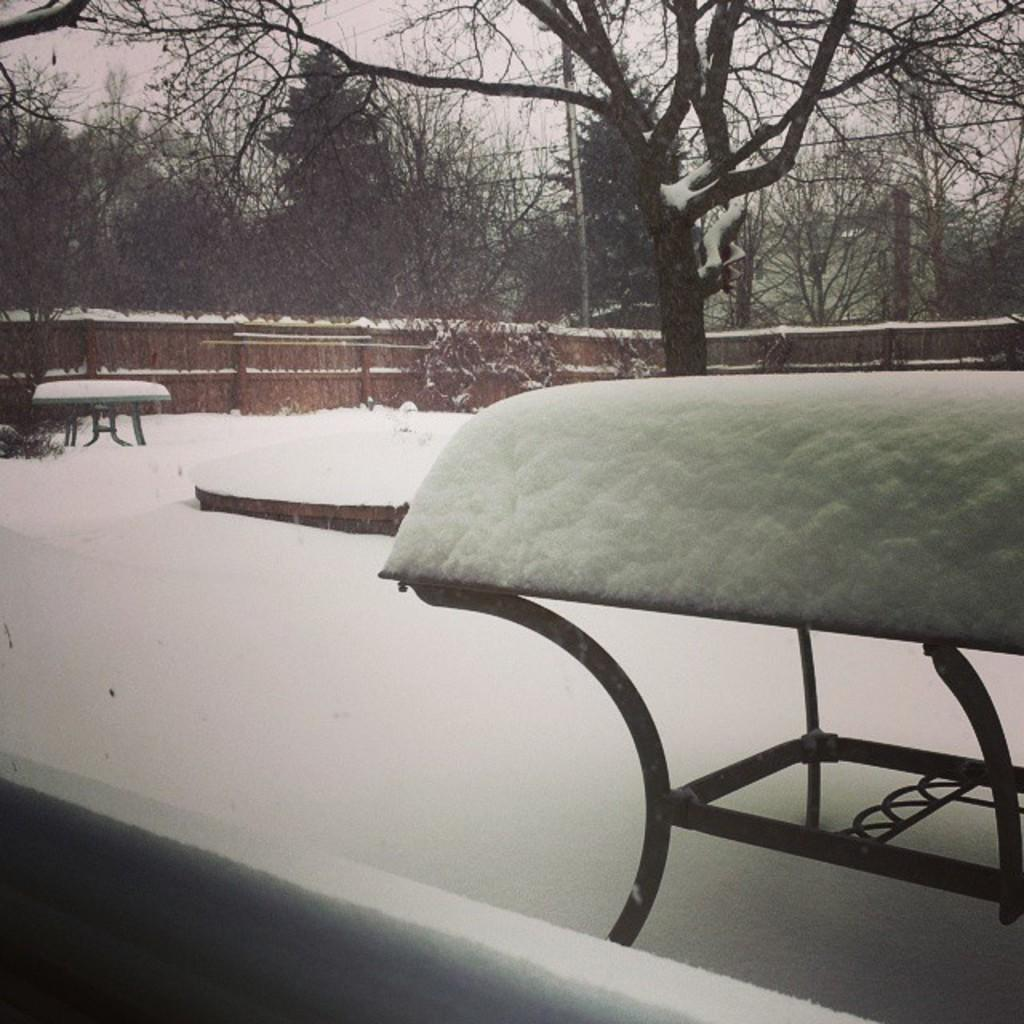What is the condition of the ground in the image? The ground is covered in snow. How many tables are on the ground in the image? There are two tables on the ground. What can be seen in the background of the image? There are trees, a wall, wires, and the sky visible in the background. Can you see a clam hanging from the wires in the background? There is no clam present in the image, and no clams are hanging from the wires in the background. 